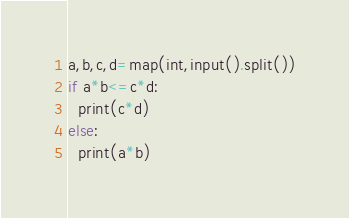<code> <loc_0><loc_0><loc_500><loc_500><_Python_>a,b,c,d=map(int,input().split())
if a*b<=c*d:
  print(c*d)
else:
  print(a*b)</code> 